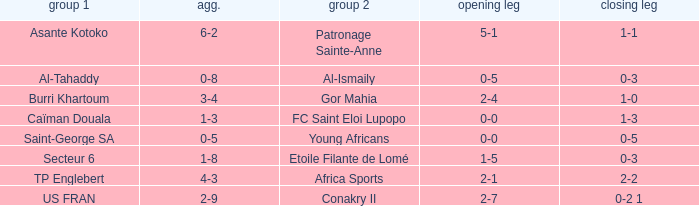Which teams had an aggregate score of 3-4? Burri Khartoum. 